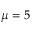<formula> <loc_0><loc_0><loc_500><loc_500>\mu = 5</formula> 